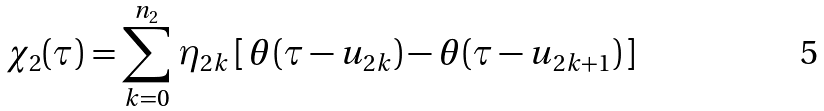Convert formula to latex. <formula><loc_0><loc_0><loc_500><loc_500>\chi _ { 2 } ( \tau ) = \sum _ { k = 0 } ^ { n _ { 2 } } \, \eta _ { 2 k } \, [ \, \theta ( \tau - u _ { 2 k } ) - \theta ( \tau - u _ { 2 k + 1 } ) \, ]</formula> 